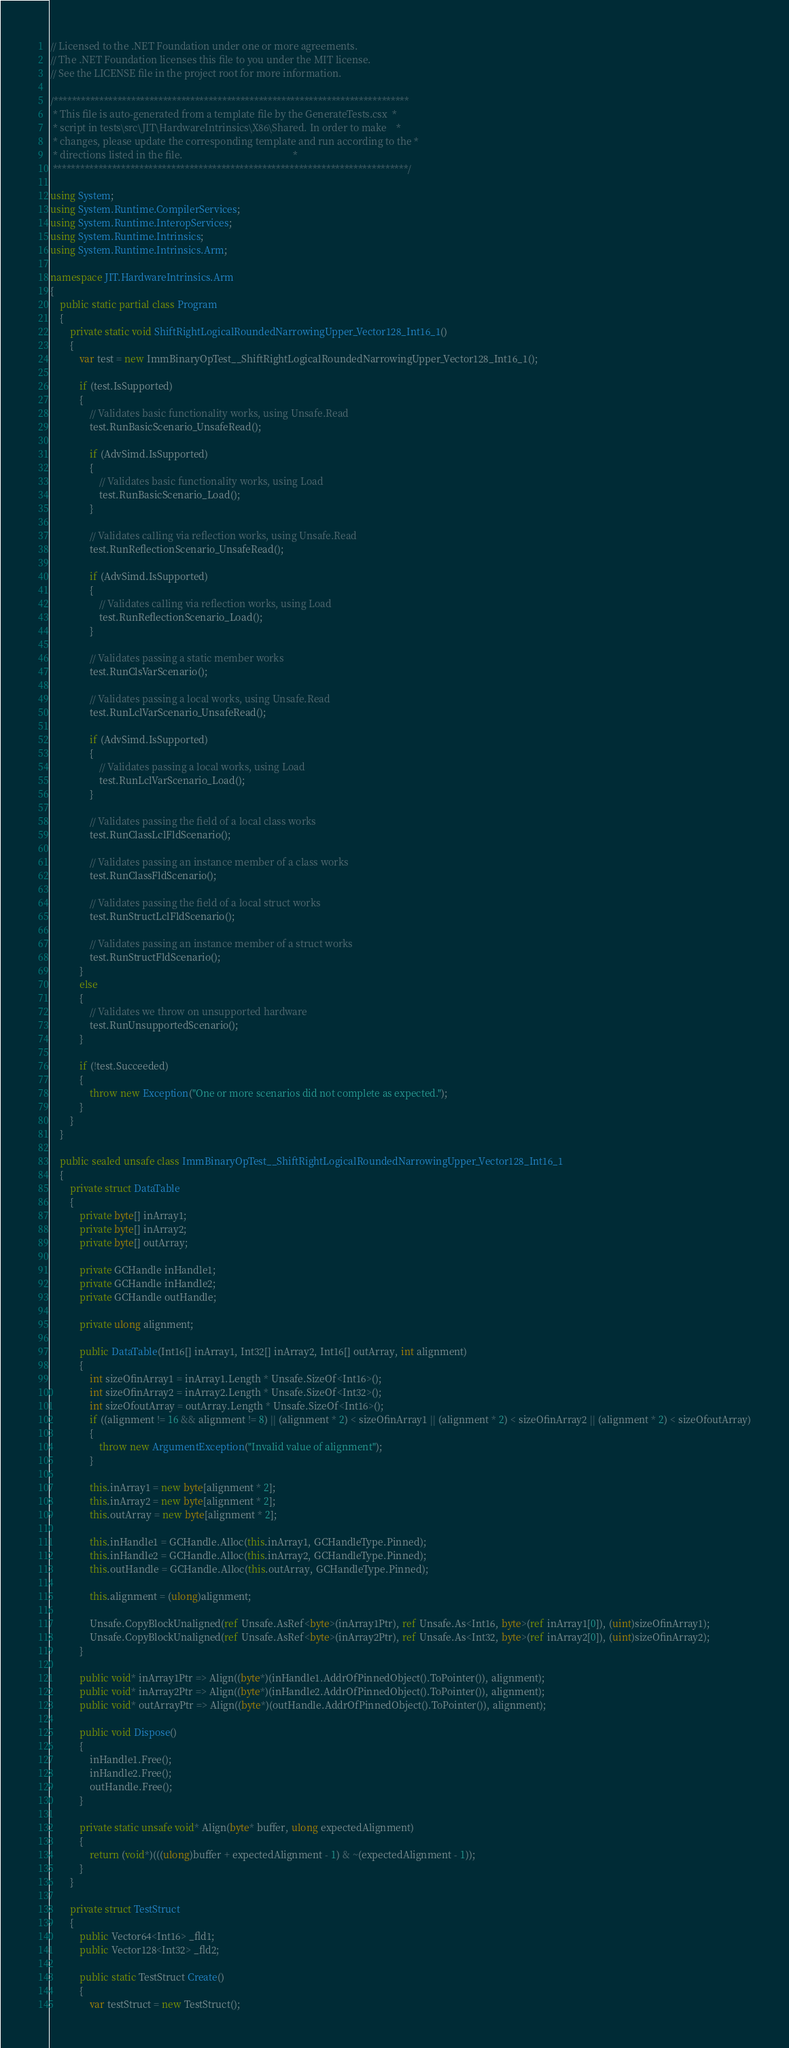<code> <loc_0><loc_0><loc_500><loc_500><_C#_>// Licensed to the .NET Foundation under one or more agreements.
// The .NET Foundation licenses this file to you under the MIT license.
// See the LICENSE file in the project root for more information.

/******************************************************************************
 * This file is auto-generated from a template file by the GenerateTests.csx  *
 * script in tests\src\JIT\HardwareIntrinsics\X86\Shared. In order to make    *
 * changes, please update the corresponding template and run according to the *
 * directions listed in the file.                                             *
 ******************************************************************************/

using System;
using System.Runtime.CompilerServices;
using System.Runtime.InteropServices;
using System.Runtime.Intrinsics;
using System.Runtime.Intrinsics.Arm;

namespace JIT.HardwareIntrinsics.Arm
{
    public static partial class Program
    {
        private static void ShiftRightLogicalRoundedNarrowingUpper_Vector128_Int16_1()
        {
            var test = new ImmBinaryOpTest__ShiftRightLogicalRoundedNarrowingUpper_Vector128_Int16_1();

            if (test.IsSupported)
            {
                // Validates basic functionality works, using Unsafe.Read
                test.RunBasicScenario_UnsafeRead();

                if (AdvSimd.IsSupported)
                {
                    // Validates basic functionality works, using Load
                    test.RunBasicScenario_Load();
                }

                // Validates calling via reflection works, using Unsafe.Read
                test.RunReflectionScenario_UnsafeRead();

                if (AdvSimd.IsSupported)
                {
                    // Validates calling via reflection works, using Load
                    test.RunReflectionScenario_Load();
                }

                // Validates passing a static member works
                test.RunClsVarScenario();

                // Validates passing a local works, using Unsafe.Read
                test.RunLclVarScenario_UnsafeRead();

                if (AdvSimd.IsSupported)
                {
                    // Validates passing a local works, using Load
                    test.RunLclVarScenario_Load();
                }

                // Validates passing the field of a local class works
                test.RunClassLclFldScenario();

                // Validates passing an instance member of a class works
                test.RunClassFldScenario();

                // Validates passing the field of a local struct works
                test.RunStructLclFldScenario();

                // Validates passing an instance member of a struct works
                test.RunStructFldScenario();
            }
            else
            {
                // Validates we throw on unsupported hardware
                test.RunUnsupportedScenario();
            }

            if (!test.Succeeded)
            {
                throw new Exception("One or more scenarios did not complete as expected.");
            }
        }
    }

    public sealed unsafe class ImmBinaryOpTest__ShiftRightLogicalRoundedNarrowingUpper_Vector128_Int16_1
    {
        private struct DataTable
        {
            private byte[] inArray1;
            private byte[] inArray2;
            private byte[] outArray;

            private GCHandle inHandle1;
            private GCHandle inHandle2;
            private GCHandle outHandle;

            private ulong alignment;

            public DataTable(Int16[] inArray1, Int32[] inArray2, Int16[] outArray, int alignment)
            {
                int sizeOfinArray1 = inArray1.Length * Unsafe.SizeOf<Int16>();
                int sizeOfinArray2 = inArray2.Length * Unsafe.SizeOf<Int32>();
                int sizeOfoutArray = outArray.Length * Unsafe.SizeOf<Int16>();
                if ((alignment != 16 && alignment != 8) || (alignment * 2) < sizeOfinArray1 || (alignment * 2) < sizeOfinArray2 || (alignment * 2) < sizeOfoutArray)
                {
                    throw new ArgumentException("Invalid value of alignment");
                }

                this.inArray1 = new byte[alignment * 2];
                this.inArray2 = new byte[alignment * 2];
                this.outArray = new byte[alignment * 2];

                this.inHandle1 = GCHandle.Alloc(this.inArray1, GCHandleType.Pinned);
                this.inHandle2 = GCHandle.Alloc(this.inArray2, GCHandleType.Pinned);
                this.outHandle = GCHandle.Alloc(this.outArray, GCHandleType.Pinned);

                this.alignment = (ulong)alignment;

                Unsafe.CopyBlockUnaligned(ref Unsafe.AsRef<byte>(inArray1Ptr), ref Unsafe.As<Int16, byte>(ref inArray1[0]), (uint)sizeOfinArray1);
                Unsafe.CopyBlockUnaligned(ref Unsafe.AsRef<byte>(inArray2Ptr), ref Unsafe.As<Int32, byte>(ref inArray2[0]), (uint)sizeOfinArray2);
            }

            public void* inArray1Ptr => Align((byte*)(inHandle1.AddrOfPinnedObject().ToPointer()), alignment);
            public void* inArray2Ptr => Align((byte*)(inHandle2.AddrOfPinnedObject().ToPointer()), alignment);
            public void* outArrayPtr => Align((byte*)(outHandle.AddrOfPinnedObject().ToPointer()), alignment);

            public void Dispose()
            {
                inHandle1.Free();
                inHandle2.Free();
                outHandle.Free();
            }

            private static unsafe void* Align(byte* buffer, ulong expectedAlignment)
            {
                return (void*)(((ulong)buffer + expectedAlignment - 1) & ~(expectedAlignment - 1));
            }
        }

        private struct TestStruct
        {
            public Vector64<Int16> _fld1;
            public Vector128<Int32> _fld2;

            public static TestStruct Create()
            {
                var testStruct = new TestStruct();
</code> 